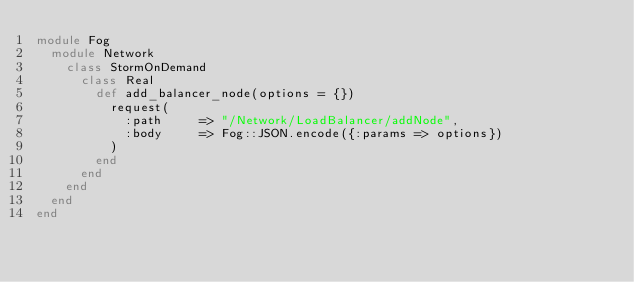Convert code to text. <code><loc_0><loc_0><loc_500><loc_500><_Ruby_>module Fog
  module Network
    class StormOnDemand
      class Real
        def add_balancer_node(options = {})
          request(
            :path     => "/Network/LoadBalancer/addNode",
            :body     => Fog::JSON.encode({:params => options})
          )
        end
      end
    end
  end
end
</code> 